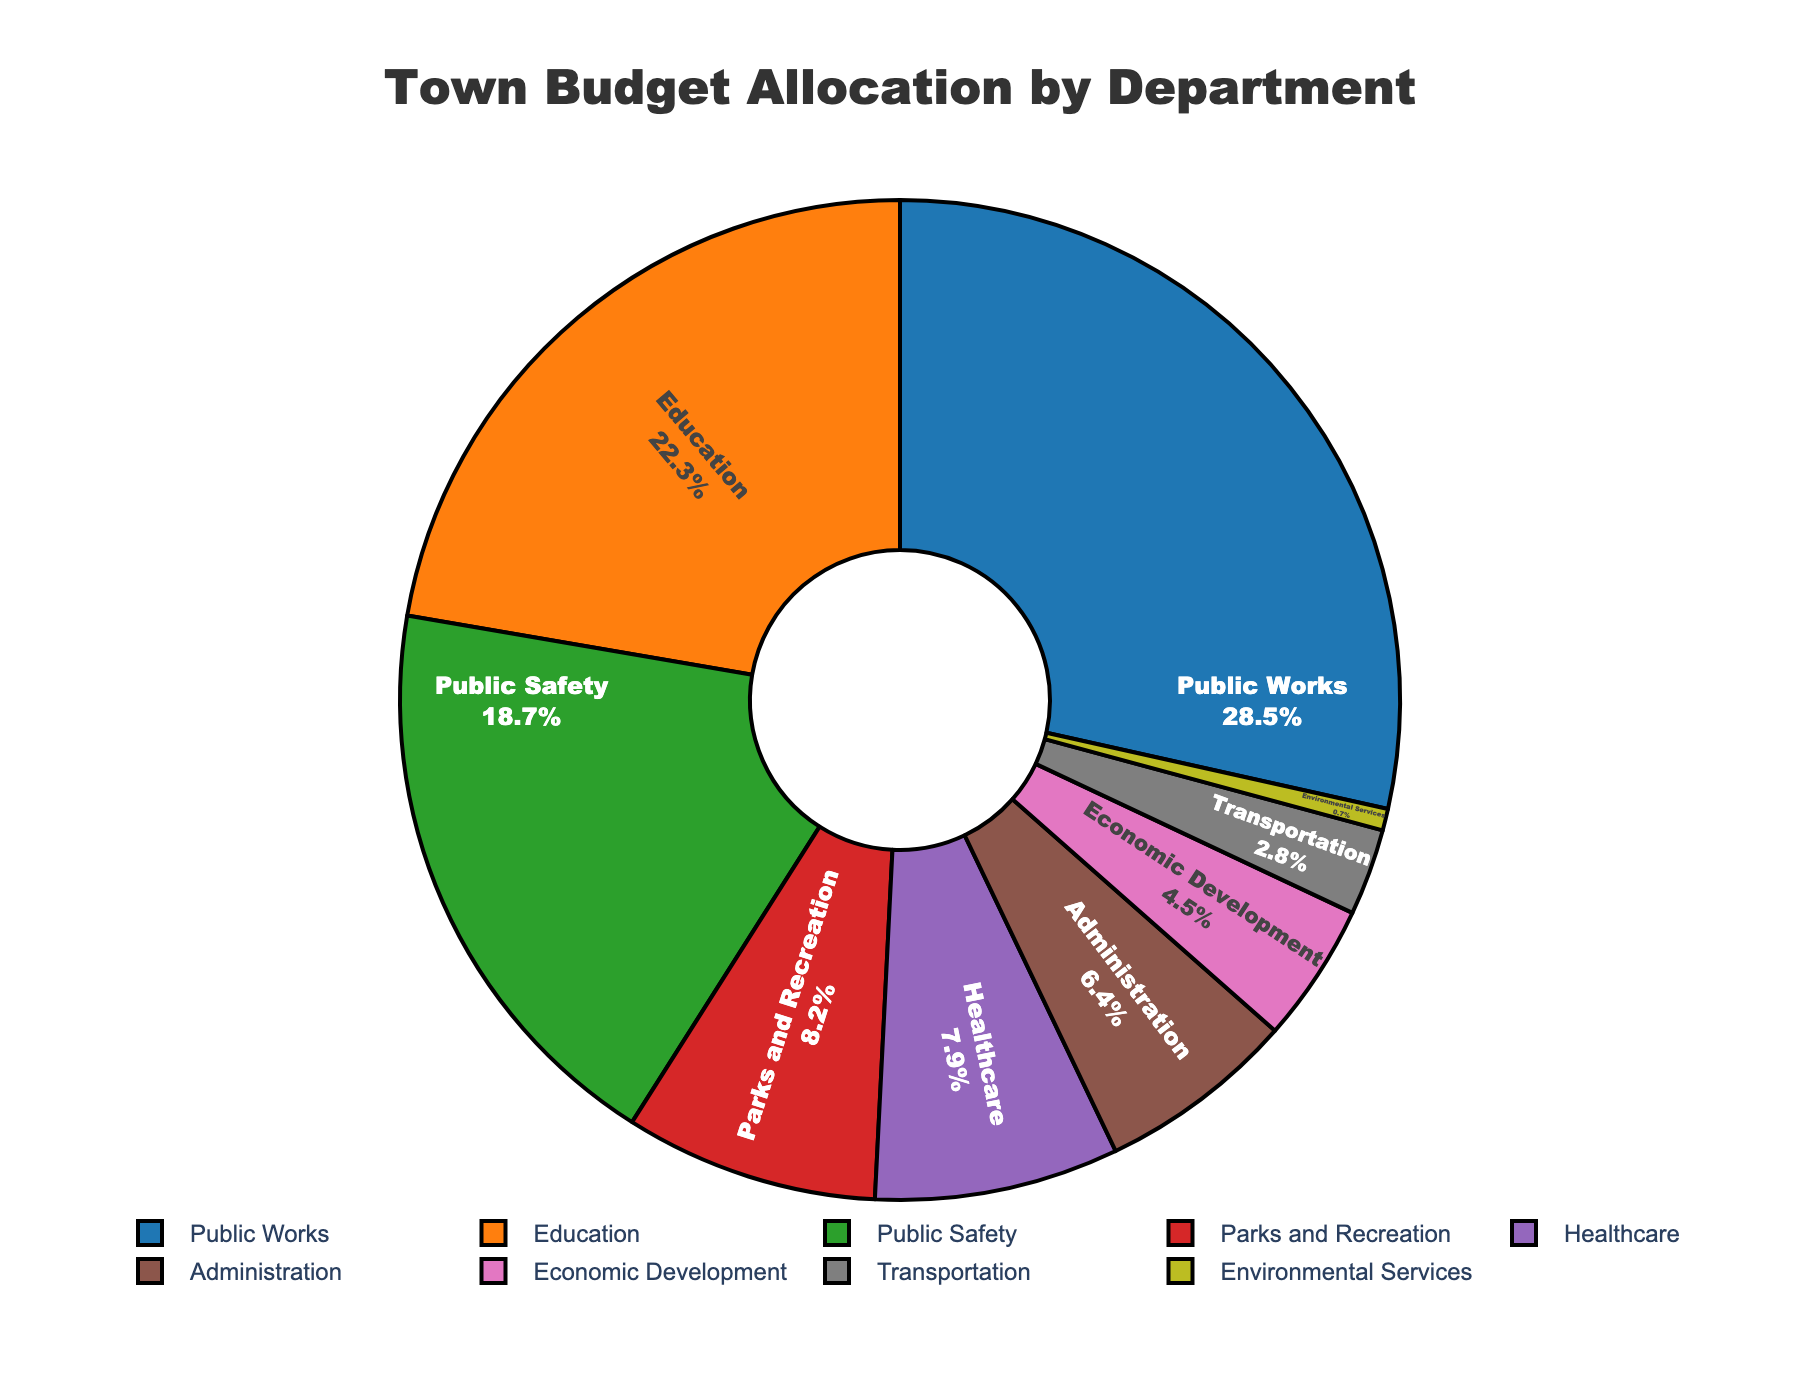What department has the highest budget allocation? The department with the largest slice of the pie chart is Public Works.
Answer: Public Works What percentage of the budget is allocated to Education? Find the slice labeled Education in the pie chart, which states the percentage allocated.
Answer: 22.3% Is the budget allocation for Public Safety greater than the allocation for Healthcare? Compare the percentages shown in the slices labeled Public Safety and Healthcare. Public Safety has 18.7%, and Healthcare has 7.9%.
Answer: Yes Which department gets less than 5% of the total budget? The slices that represent less than 5% include Economic Development, Transportation, and Environmental Services.
Answer: Economic Development, Transportation, and Environmental Services What is the combined budget allocation for Parks and Recreation and Administration? Add the percentages for Parks and Recreation (8.2%) and Administration (6.4%): 8.2% + 6.4% = 14.6%.
Answer: 14.6% How does the allocation for Transportation compare to Economic Development? Compare the slices for Transportation (2.8%) and Economic Development (4.5%).
Answer: Transportation is less than Economic Development What is the difference in budget percentage between Public Works and Public Safety? Subtract the percentage for Public Safety from the percentage for Public Works: 28.5% - 18.7% = 9.8%.
Answer: 9.8% What is the smallest budget allocation, and which department does it belong to? Identify the smallest slice in the pie chart, which belongs to Environmental Services at 0.7%.
Answer: Environmental Services, 0.7% What is the average budget allocation for the departments with more than 10% allocation? Identify departments with more than 10% (Public Works, Education, Public Safety) and calculate the average: (28.5% + 22.3% + 18.7%) / 3 = 69.5% / 3 = 23.2%.
Answer: 23.2% Does the Public Works budget allocation exceed the combined allocation for Healthcare and Economic Development? Add the allocations for Healthcare (7.9%) and Economic Development (4.5%): 7.9% + 4.5% = 12.4%. Public Works allocation is 28.5%, which is greater.
Answer: Yes What is the total budget allocation for the departments receiving less than 10% each? Sum the allocations for Parks and Recreation (8.2%), Healthcare (7.9%), Administration (6.4%), Economic Development (4.5%), Transportation (2.8%), and Environmental Services (0.7%): 8.2% + 7.9% + 6.4% + 4.5% + 2.8% + 0.7% = 30.5%.
Answer: 30.5% 